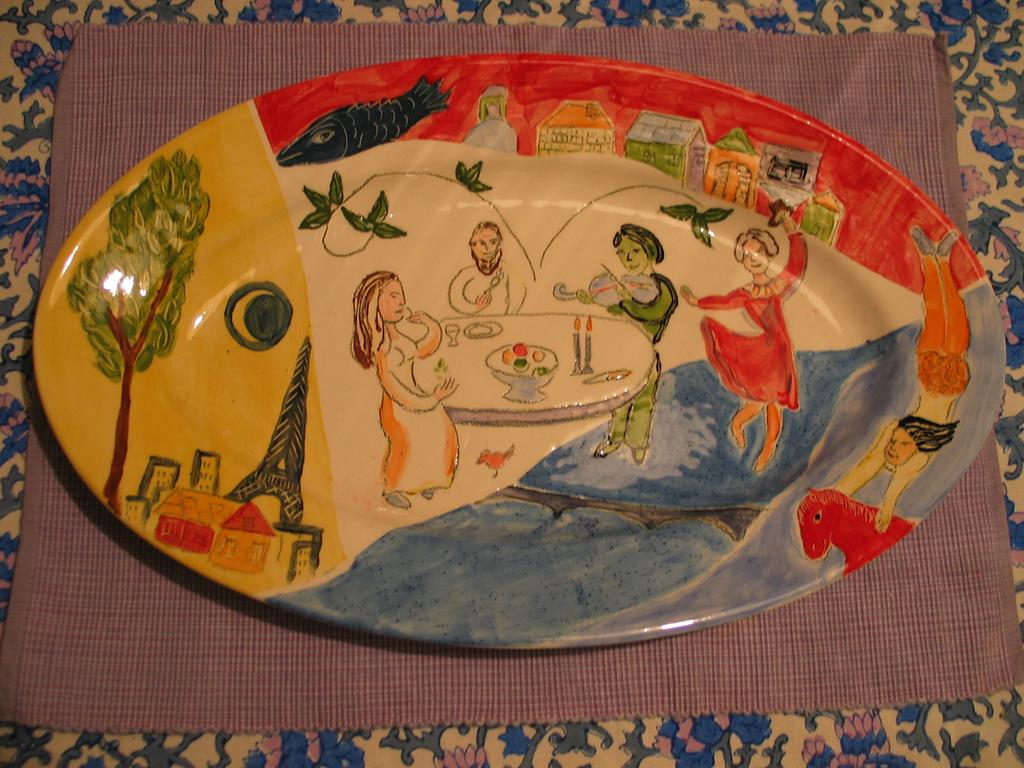What is on the plate that is visible in the image? The facts do not specify what is on the plate. What is the plate placed on? The plate is placed on a mat. Where is the mat located? The mat is placed on a table. What type of health issues can be seen in the image? There are no health issues visible in the image; it features a colored plate placed on a mat on a table. Can you tell me how many vans are parked near the table in the image? There is no van present in the image; it only shows a colored plate on a mat on a table. 